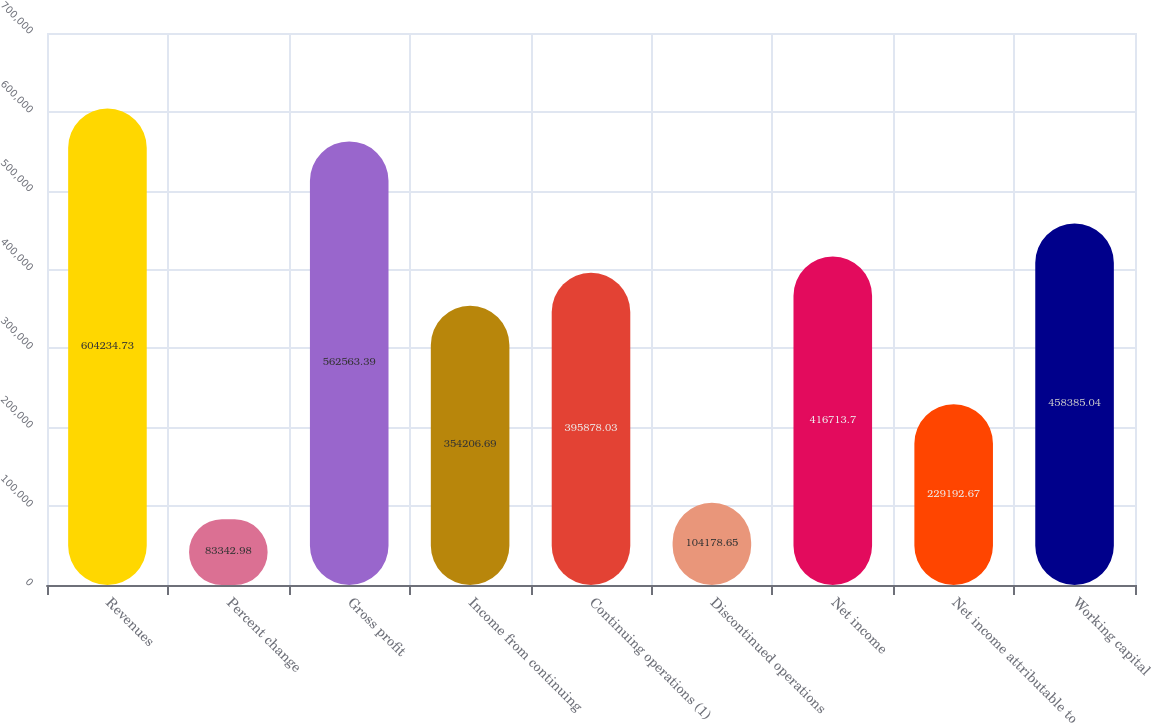Convert chart. <chart><loc_0><loc_0><loc_500><loc_500><bar_chart><fcel>Revenues<fcel>Percent change<fcel>Gross profit<fcel>Income from continuing<fcel>Continuing operations (1)<fcel>Discontinued operations<fcel>Net income<fcel>Net income attributable to<fcel>Working capital<nl><fcel>604235<fcel>83343<fcel>562563<fcel>354207<fcel>395878<fcel>104179<fcel>416714<fcel>229193<fcel>458385<nl></chart> 